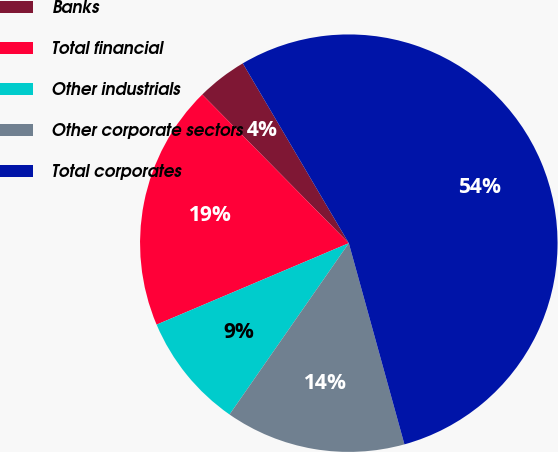Convert chart to OTSL. <chart><loc_0><loc_0><loc_500><loc_500><pie_chart><fcel>Banks<fcel>Total financial<fcel>Other industrials<fcel>Other corporate sectors<fcel>Total corporates<nl><fcel>3.91%<fcel>18.99%<fcel>8.94%<fcel>13.97%<fcel>54.18%<nl></chart> 